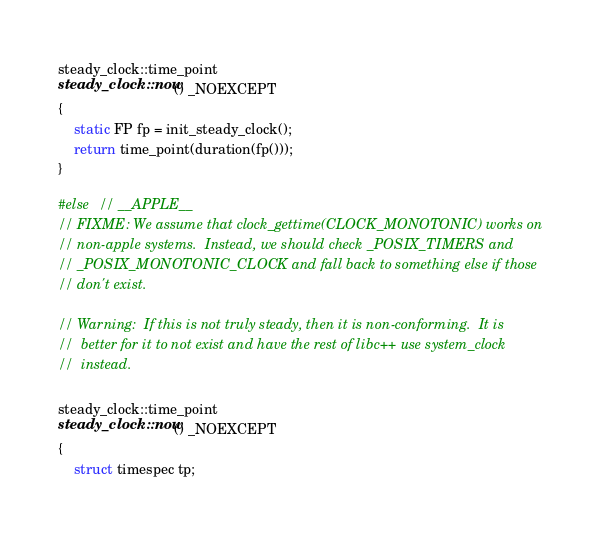<code> <loc_0><loc_0><loc_500><loc_500><_C++_>steady_clock::time_point
steady_clock::now() _NOEXCEPT
{
    static FP fp = init_steady_clock();
    return time_point(duration(fp()));
}

#else  // __APPLE__
// FIXME: We assume that clock_gettime(CLOCK_MONOTONIC) works on
// non-apple systems.  Instead, we should check _POSIX_TIMERS and
// _POSIX_MONOTONIC_CLOCK and fall back to something else if those
// don't exist.

// Warning:  If this is not truly steady, then it is non-conforming.  It is
//  better for it to not exist and have the rest of libc++ use system_clock
//  instead.

steady_clock::time_point
steady_clock::now() _NOEXCEPT
{
    struct timespec tp;</code> 